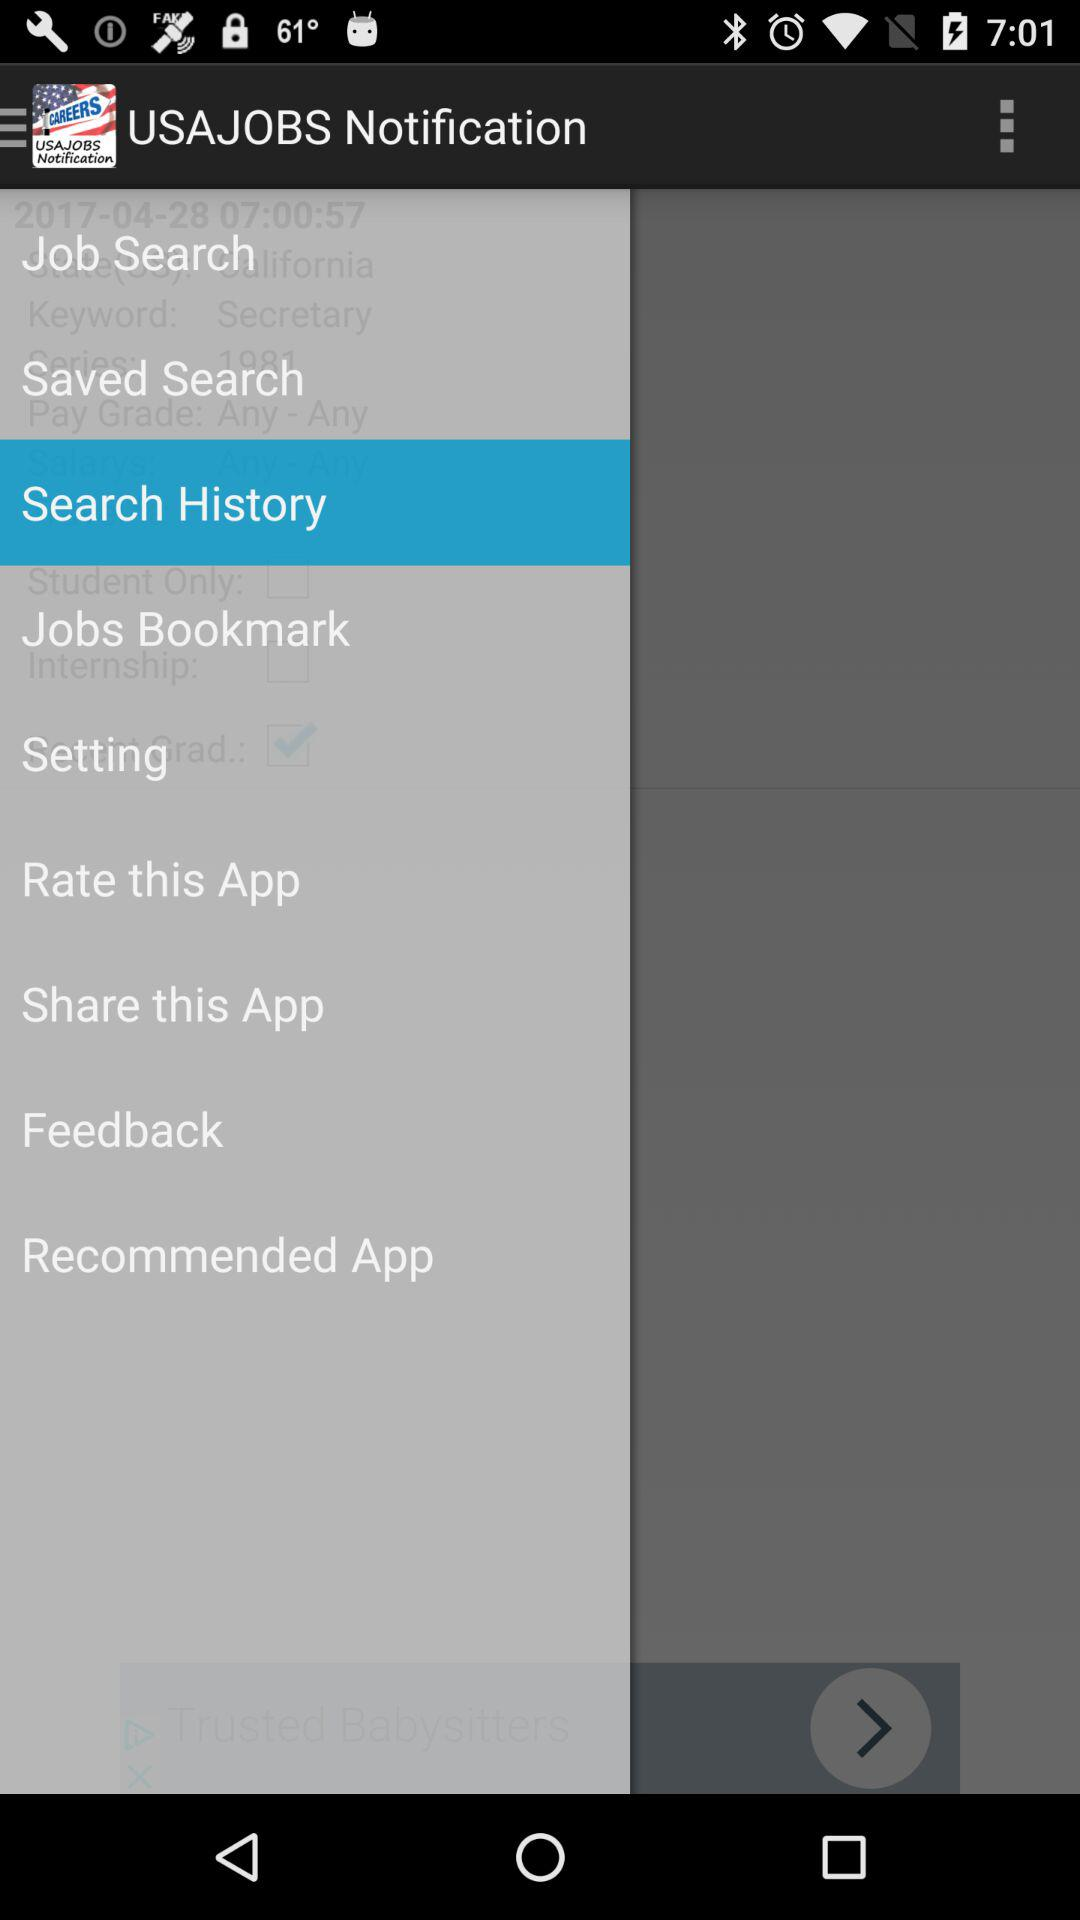What is the name of the application? The name of the application is "USAJOBS Notification". 